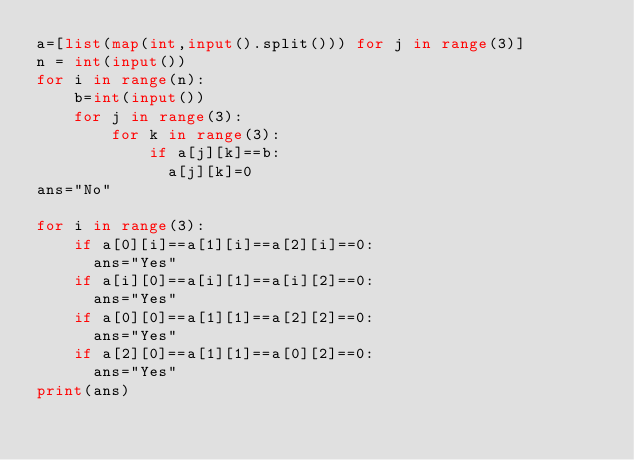Convert code to text. <code><loc_0><loc_0><loc_500><loc_500><_Python_>a=[list(map(int,input().split())) for j in range(3)]
n = int(input())
for i in range(n):
    b=int(input())
    for j in range(3):
        for k in range(3):
            if a[j][k]==b:
              a[j][k]=0
ans="No"

for i in range(3):
    if a[0][i]==a[1][i]==a[2][i]==0:
      ans="Yes"
    if a[i][0]==a[i][1]==a[i][2]==0:
      ans="Yes"
    if a[0][0]==a[1][1]==a[2][2]==0:
      ans="Yes"
    if a[2][0]==a[1][1]==a[0][2]==0:
      ans="Yes"
print(ans)
</code> 